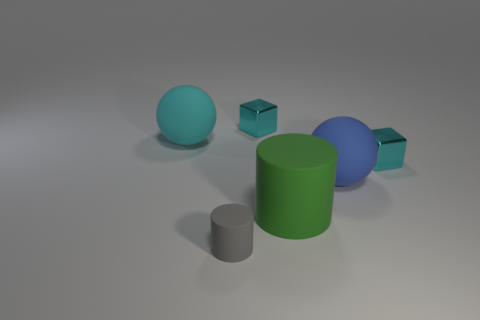Is there anything else that is the same shape as the blue object?
Offer a terse response. Yes. Are there more cyan cubes that are in front of the cyan matte sphere than tiny blue metal balls?
Your answer should be compact. Yes. There is a cyan shiny thing that is to the right of the green thing; what number of tiny gray cylinders are right of it?
Ensure brevity in your answer.  0. What is the shape of the cyan metal object that is behind the tiny cyan shiny cube that is in front of the small metallic cube to the left of the big blue matte ball?
Offer a terse response. Cube. How big is the blue rubber ball?
Offer a very short reply. Large. Is there a cyan object that has the same material as the blue ball?
Make the answer very short. Yes. There is a cyan object that is the same shape as the blue matte thing; what is its size?
Offer a terse response. Large. Is the number of big blue spheres that are on the left side of the green object the same as the number of big purple cylinders?
Keep it short and to the point. Yes. There is a matte thing behind the blue thing; does it have the same shape as the blue matte object?
Keep it short and to the point. Yes. What is the shape of the tiny gray thing?
Your answer should be compact. Cylinder. 